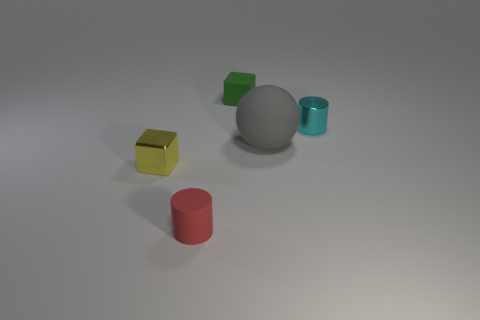Add 1 small green rubber blocks. How many objects exist? 6 Subtract all cylinders. How many objects are left? 3 Add 5 yellow metallic cubes. How many yellow metallic cubes exist? 6 Subtract 0 green spheres. How many objects are left? 5 Subtract all gray rubber balls. Subtract all small objects. How many objects are left? 0 Add 2 small red matte objects. How many small red matte objects are left? 3 